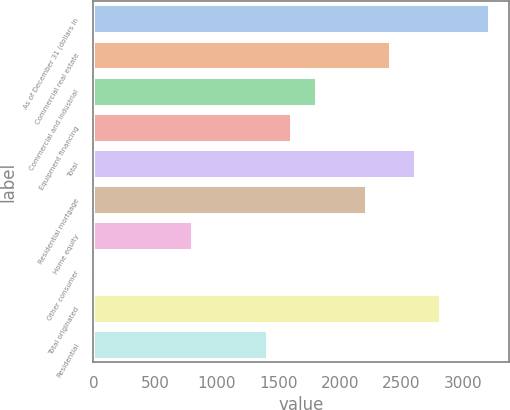Convert chart. <chart><loc_0><loc_0><loc_500><loc_500><bar_chart><fcel>As of December 31 (dollars in<fcel>Commercial real estate<fcel>Commercial and industrial<fcel>Equipment financing<fcel>Total<fcel>Residential mortgage<fcel>Home equity<fcel>Other consumer<fcel>Total originated<fcel>Residential<nl><fcel>3215.64<fcel>2411.88<fcel>1809.06<fcel>1608.12<fcel>2612.82<fcel>2210.94<fcel>804.36<fcel>0.6<fcel>2813.76<fcel>1407.18<nl></chart> 